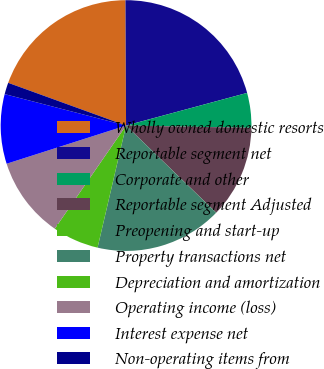<chart> <loc_0><loc_0><loc_500><loc_500><pie_chart><fcel>Wholly owned domestic resorts<fcel>Reportable segment net<fcel>Corporate and other<fcel>Reportable segment Adjusted<fcel>Preopening and start-up<fcel>Property transactions net<fcel>Depreciation and amortization<fcel>Operating income (loss)<fcel>Interest expense net<fcel>Non-operating items from<nl><fcel>19.39%<fcel>20.88%<fcel>4.48%<fcel>11.94%<fcel>0.01%<fcel>16.41%<fcel>5.97%<fcel>10.45%<fcel>8.96%<fcel>1.5%<nl></chart> 